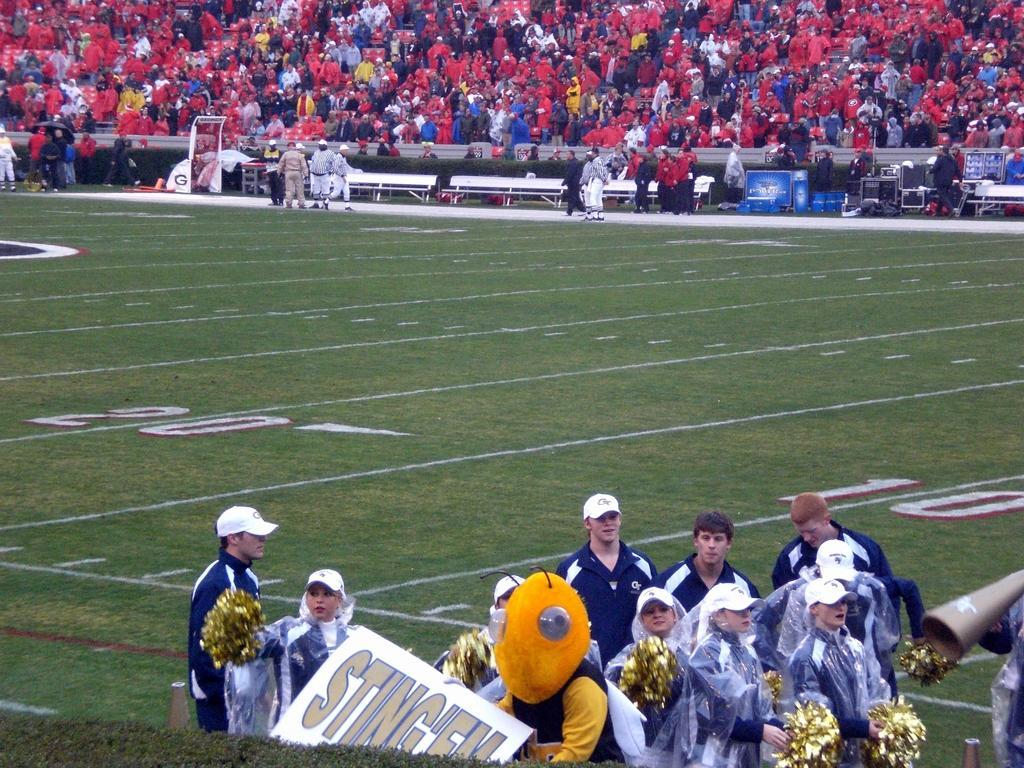Describe this image in one or two sentences. This image looks like a stadium, we can see a few people among them, some people are standing on the ground and some people are standing in the background, we can see some objects on the ground, like benches, posters, speakers and other things. 